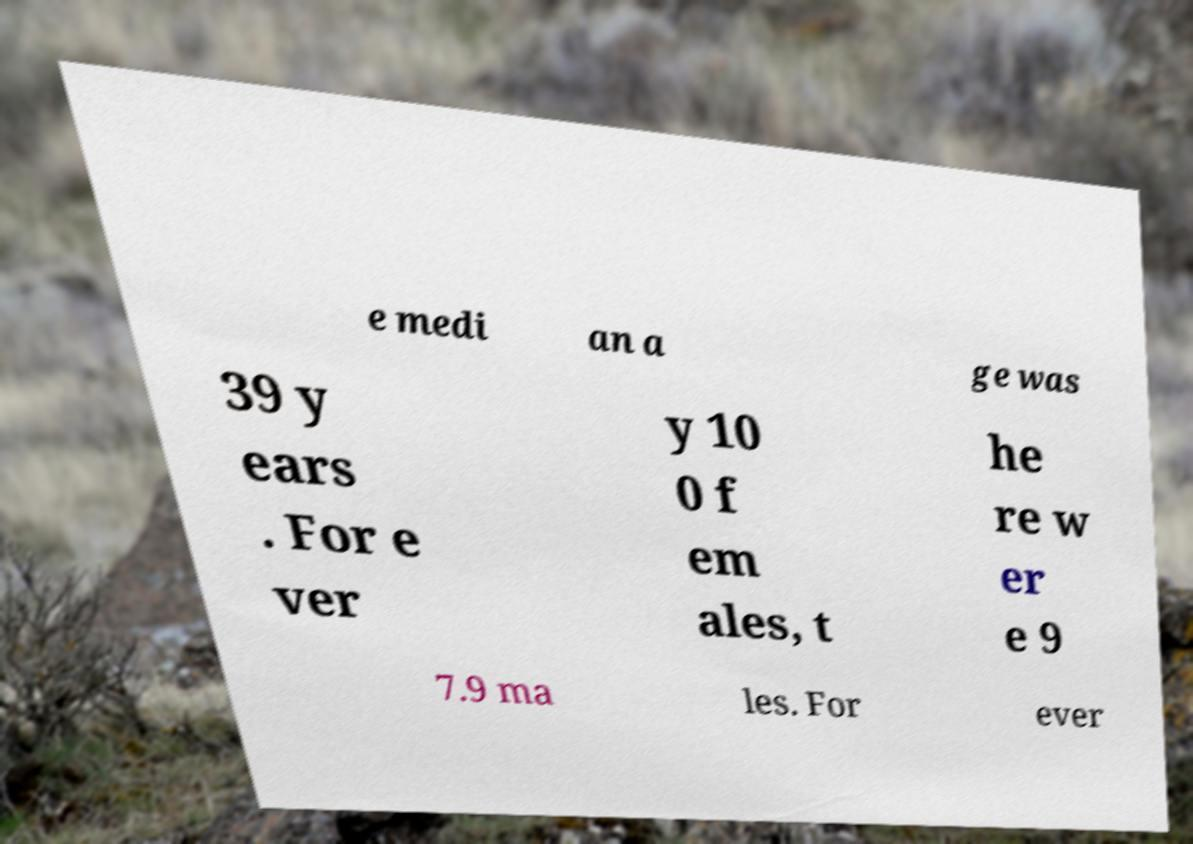Please identify and transcribe the text found in this image. e medi an a ge was 39 y ears . For e ver y 10 0 f em ales, t he re w er e 9 7.9 ma les. For ever 